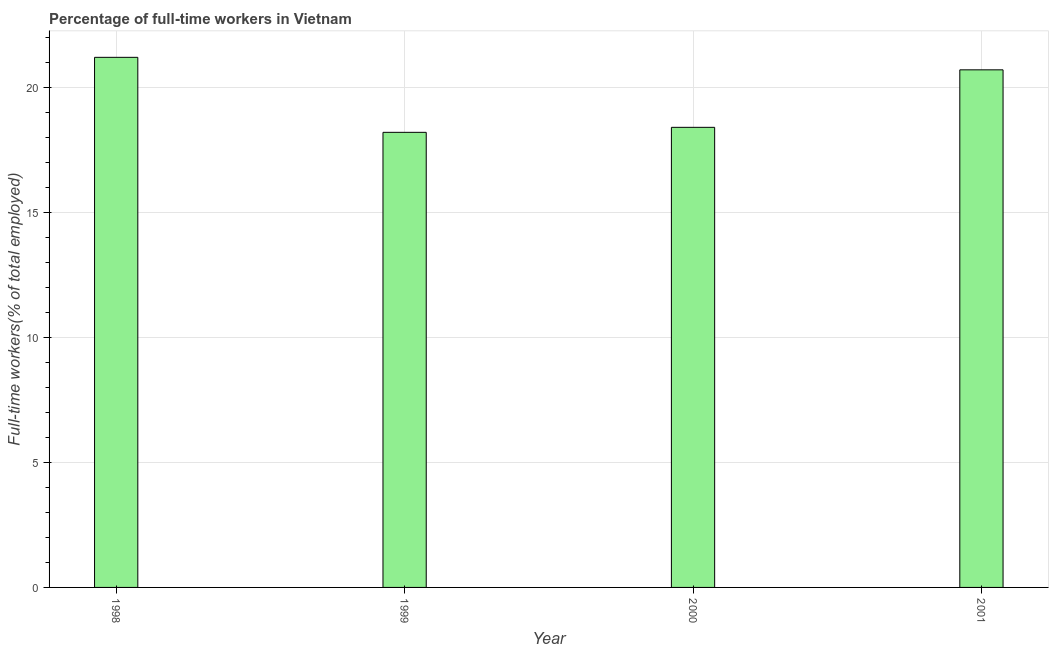Does the graph contain any zero values?
Your response must be concise. No. Does the graph contain grids?
Offer a terse response. Yes. What is the title of the graph?
Keep it short and to the point. Percentage of full-time workers in Vietnam. What is the label or title of the Y-axis?
Keep it short and to the point. Full-time workers(% of total employed). What is the percentage of full-time workers in 2001?
Provide a succinct answer. 20.7. Across all years, what is the maximum percentage of full-time workers?
Offer a terse response. 21.2. Across all years, what is the minimum percentage of full-time workers?
Provide a succinct answer. 18.2. In which year was the percentage of full-time workers maximum?
Your answer should be compact. 1998. In which year was the percentage of full-time workers minimum?
Your answer should be compact. 1999. What is the sum of the percentage of full-time workers?
Provide a short and direct response. 78.5. What is the average percentage of full-time workers per year?
Provide a short and direct response. 19.62. What is the median percentage of full-time workers?
Offer a very short reply. 19.55. In how many years, is the percentage of full-time workers greater than 6 %?
Offer a terse response. 4. What is the ratio of the percentage of full-time workers in 2000 to that in 2001?
Ensure brevity in your answer.  0.89. Is the percentage of full-time workers in 1998 less than that in 1999?
Provide a succinct answer. No. How many years are there in the graph?
Provide a succinct answer. 4. What is the Full-time workers(% of total employed) in 1998?
Provide a short and direct response. 21.2. What is the Full-time workers(% of total employed) in 1999?
Ensure brevity in your answer.  18.2. What is the Full-time workers(% of total employed) in 2000?
Offer a very short reply. 18.4. What is the Full-time workers(% of total employed) in 2001?
Your answer should be very brief. 20.7. What is the difference between the Full-time workers(% of total employed) in 1998 and 1999?
Make the answer very short. 3. What is the difference between the Full-time workers(% of total employed) in 1999 and 2001?
Ensure brevity in your answer.  -2.5. What is the ratio of the Full-time workers(% of total employed) in 1998 to that in 1999?
Offer a terse response. 1.17. What is the ratio of the Full-time workers(% of total employed) in 1998 to that in 2000?
Your answer should be compact. 1.15. What is the ratio of the Full-time workers(% of total employed) in 1999 to that in 2001?
Keep it short and to the point. 0.88. What is the ratio of the Full-time workers(% of total employed) in 2000 to that in 2001?
Provide a succinct answer. 0.89. 